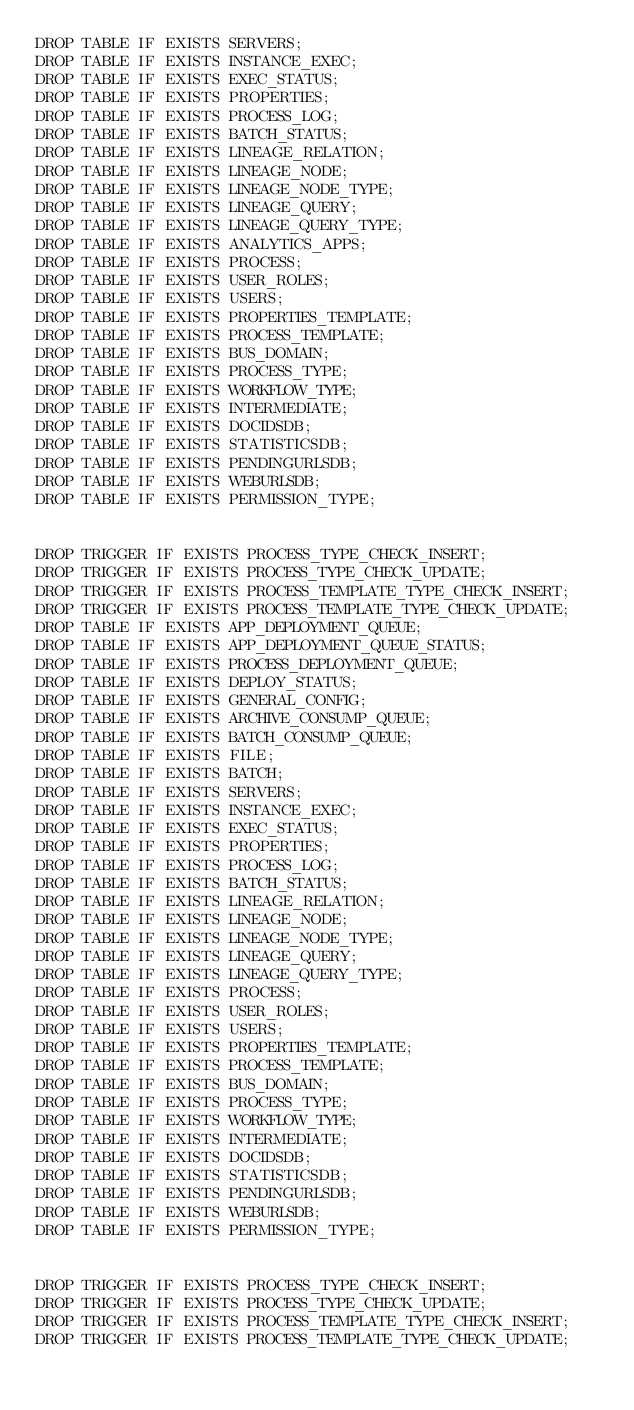<code> <loc_0><loc_0><loc_500><loc_500><_SQL_>DROP TABLE IF EXISTS SERVERS;
DROP TABLE IF EXISTS INSTANCE_EXEC;
DROP TABLE IF EXISTS EXEC_STATUS;
DROP TABLE IF EXISTS PROPERTIES;
DROP TABLE IF EXISTS PROCESS_LOG;
DROP TABLE IF EXISTS BATCH_STATUS;
DROP TABLE IF EXISTS LINEAGE_RELATION;
DROP TABLE IF EXISTS LINEAGE_NODE;
DROP TABLE IF EXISTS LINEAGE_NODE_TYPE;
DROP TABLE IF EXISTS LINEAGE_QUERY;
DROP TABLE IF EXISTS LINEAGE_QUERY_TYPE;
DROP TABLE IF EXISTS ANALYTICS_APPS;
DROP TABLE IF EXISTS PROCESS;
DROP TABLE IF EXISTS USER_ROLES;
DROP TABLE IF EXISTS USERS;
DROP TABLE IF EXISTS PROPERTIES_TEMPLATE;
DROP TABLE IF EXISTS PROCESS_TEMPLATE;
DROP TABLE IF EXISTS BUS_DOMAIN;
DROP TABLE IF EXISTS PROCESS_TYPE;
DROP TABLE IF EXISTS WORKFLOW_TYPE;
DROP TABLE IF EXISTS INTERMEDIATE;
DROP TABLE IF EXISTS DOCIDSDB;
DROP TABLE IF EXISTS STATISTICSDB;
DROP TABLE IF EXISTS PENDINGURLSDB;
DROP TABLE IF EXISTS WEBURLSDB;
DROP TABLE IF EXISTS PERMISSION_TYPE;


DROP TRIGGER IF EXISTS PROCESS_TYPE_CHECK_INSERT;
DROP TRIGGER IF EXISTS PROCESS_TYPE_CHECK_UPDATE;
DROP TRIGGER IF EXISTS PROCESS_TEMPLATE_TYPE_CHECK_INSERT;
DROP TRIGGER IF EXISTS PROCESS_TEMPLATE_TYPE_CHECK_UPDATE;
DROP TABLE IF EXISTS APP_DEPLOYMENT_QUEUE;
DROP TABLE IF EXISTS APP_DEPLOYMENT_QUEUE_STATUS;
DROP TABLE IF EXISTS PROCESS_DEPLOYMENT_QUEUE;
DROP TABLE IF EXISTS DEPLOY_STATUS;
DROP TABLE IF EXISTS GENERAL_CONFIG;
DROP TABLE IF EXISTS ARCHIVE_CONSUMP_QUEUE;
DROP TABLE IF EXISTS BATCH_CONSUMP_QUEUE;
DROP TABLE IF EXISTS FILE;
DROP TABLE IF EXISTS BATCH;
DROP TABLE IF EXISTS SERVERS;
DROP TABLE IF EXISTS INSTANCE_EXEC;
DROP TABLE IF EXISTS EXEC_STATUS;
DROP TABLE IF EXISTS PROPERTIES;
DROP TABLE IF EXISTS PROCESS_LOG;
DROP TABLE IF EXISTS BATCH_STATUS;
DROP TABLE IF EXISTS LINEAGE_RELATION;
DROP TABLE IF EXISTS LINEAGE_NODE;
DROP TABLE IF EXISTS LINEAGE_NODE_TYPE;
DROP TABLE IF EXISTS LINEAGE_QUERY;
DROP TABLE IF EXISTS LINEAGE_QUERY_TYPE;
DROP TABLE IF EXISTS PROCESS;
DROP TABLE IF EXISTS USER_ROLES;
DROP TABLE IF EXISTS USERS;
DROP TABLE IF EXISTS PROPERTIES_TEMPLATE;
DROP TABLE IF EXISTS PROCESS_TEMPLATE;
DROP TABLE IF EXISTS BUS_DOMAIN;
DROP TABLE IF EXISTS PROCESS_TYPE;
DROP TABLE IF EXISTS WORKFLOW_TYPE;
DROP TABLE IF EXISTS INTERMEDIATE;
DROP TABLE IF EXISTS DOCIDSDB;
DROP TABLE IF EXISTS STATISTICSDB;
DROP TABLE IF EXISTS PENDINGURLSDB;
DROP TABLE IF EXISTS WEBURLSDB;
DROP TABLE IF EXISTS PERMISSION_TYPE;


DROP TRIGGER IF EXISTS PROCESS_TYPE_CHECK_INSERT;
DROP TRIGGER IF EXISTS PROCESS_TYPE_CHECK_UPDATE;
DROP TRIGGER IF EXISTS PROCESS_TEMPLATE_TYPE_CHECK_INSERT;
DROP TRIGGER IF EXISTS PROCESS_TEMPLATE_TYPE_CHECK_UPDATE;
</code> 